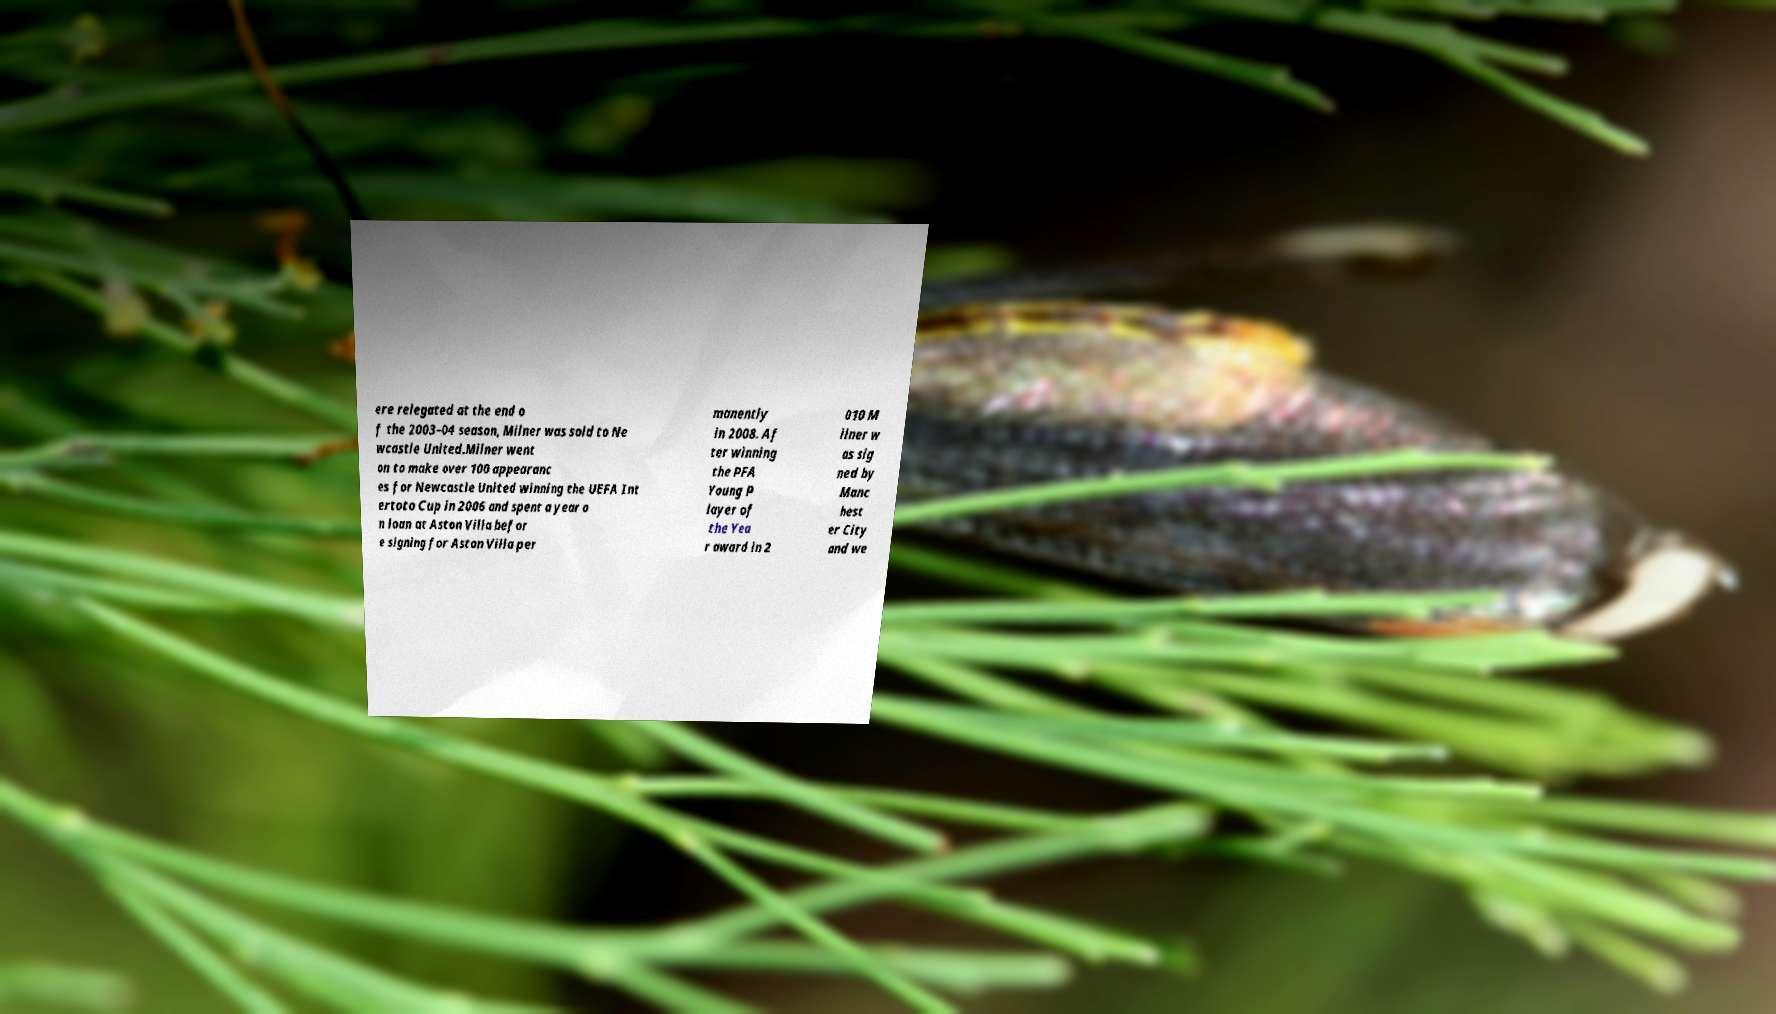Could you assist in decoding the text presented in this image and type it out clearly? ere relegated at the end o f the 2003–04 season, Milner was sold to Ne wcastle United.Milner went on to make over 100 appearanc es for Newcastle United winning the UEFA Int ertoto Cup in 2006 and spent a year o n loan at Aston Villa befor e signing for Aston Villa per manently in 2008. Af ter winning the PFA Young P layer of the Yea r award in 2 010 M ilner w as sig ned by Manc hest er City and we 